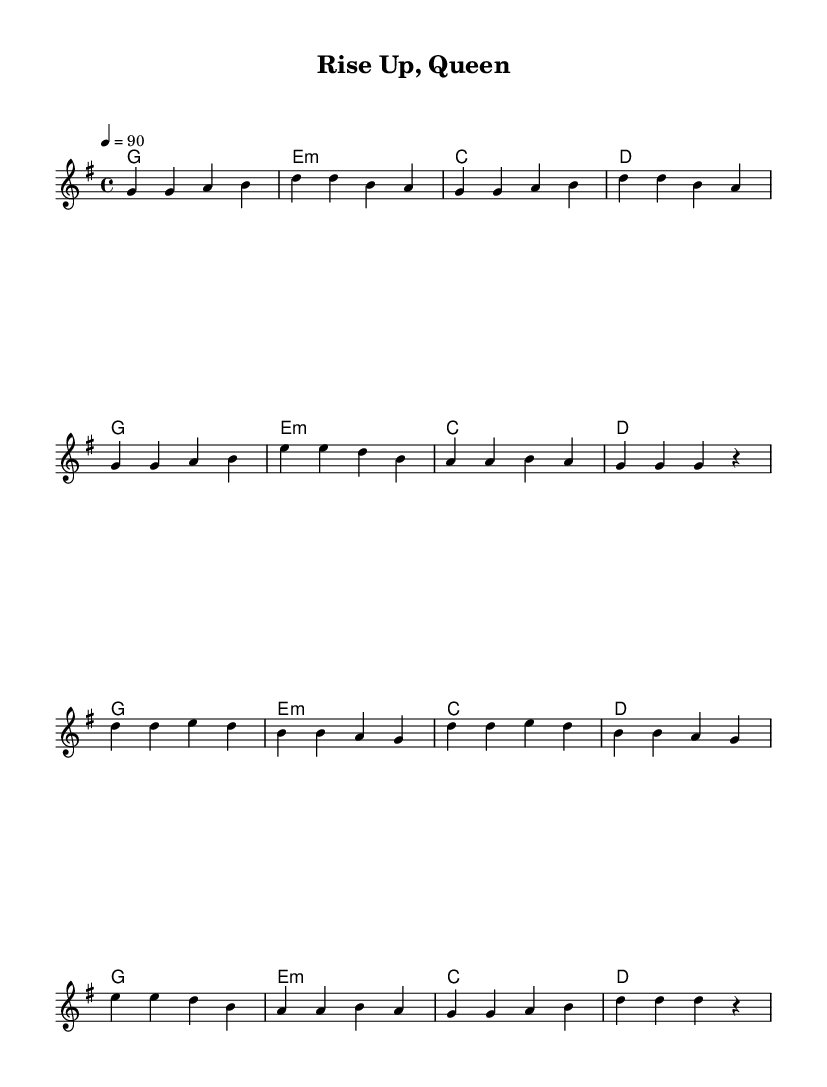What is the key signature of this music? The key signature is G major, which has one sharp (F#).
Answer: G major What is the time signature of this music? The time signature is 4/4, indicating four beats per measure.
Answer: 4/4 What is the tempo marking for this piece? The tempo marking indicates a speed of 90 beats per minute (BPM).
Answer: 90 How many measures are in the verse section? The verse consists of 8 measures as counted from the score's melody section.
Answer: 8 Which chord comes first in the verse? The first chord in the verse is G major, as indicated by the chord symbols at the start of the melody.
Answer: G What is the primary theme conveyed in the lyrics of this piece? The primary theme is female empowerment, as the title "Rise Up, Queen" suggests a celebration of independence and strength.
Answer: Female empowerment In the chorus, what is the last chord played? The last chord in the chorus is D major, following the sequence of the chorus harmonies.
Answer: D 